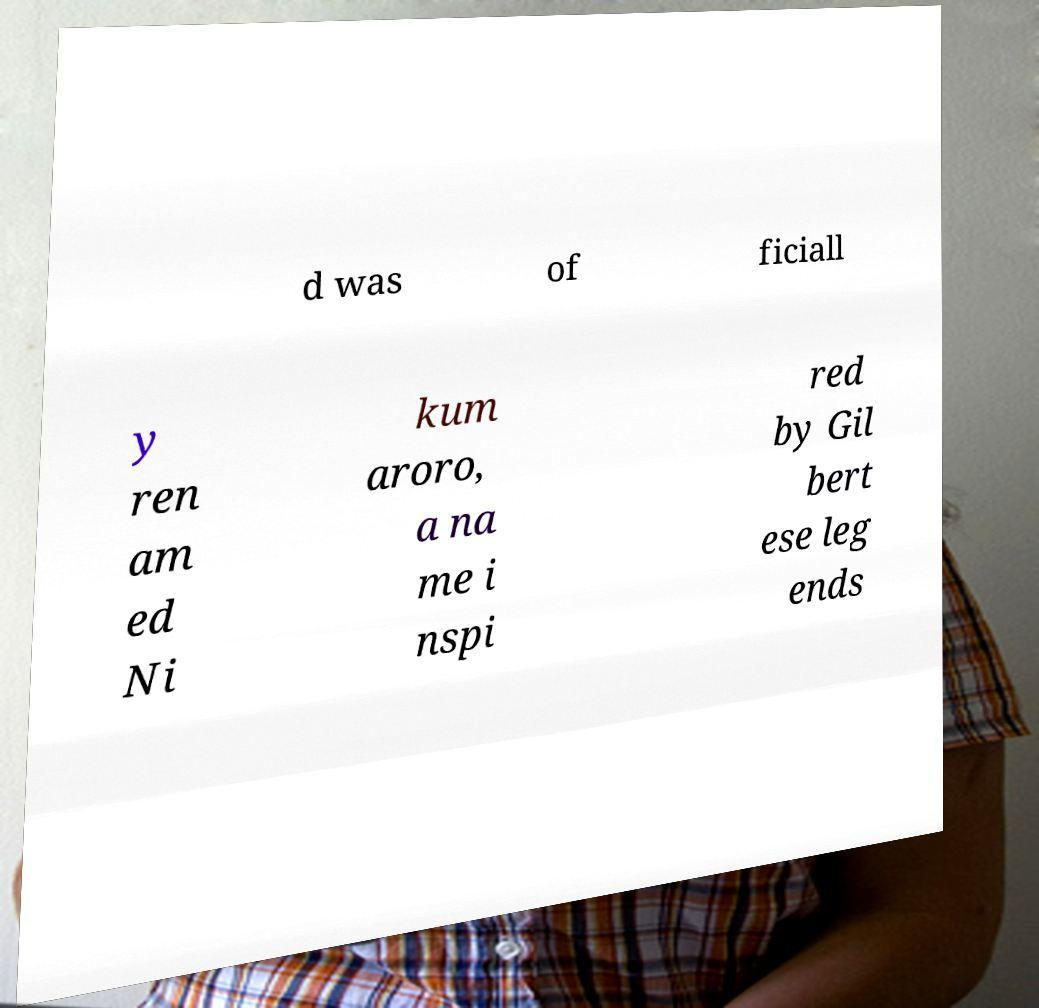Please identify and transcribe the text found in this image. d was of ficiall y ren am ed Ni kum aroro, a na me i nspi red by Gil bert ese leg ends 